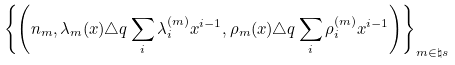Convert formula to latex. <formula><loc_0><loc_0><loc_500><loc_500>\left \{ \left ( n _ { m } , \lambda _ { m } ( x ) \triangle q \sum _ { i } \lambda ^ { ( m ) } _ { i } x ^ { i - 1 } , \rho _ { m } ( x ) \triangle q \sum _ { i } \rho ^ { ( m ) } _ { i } x ^ { i - 1 } \right ) \right \} _ { m \in \natural s }</formula> 